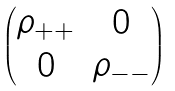Convert formula to latex. <formula><loc_0><loc_0><loc_500><loc_500>\begin{pmatrix} \rho _ { + + } & 0 \\ 0 & \rho _ { - - } \end{pmatrix}</formula> 